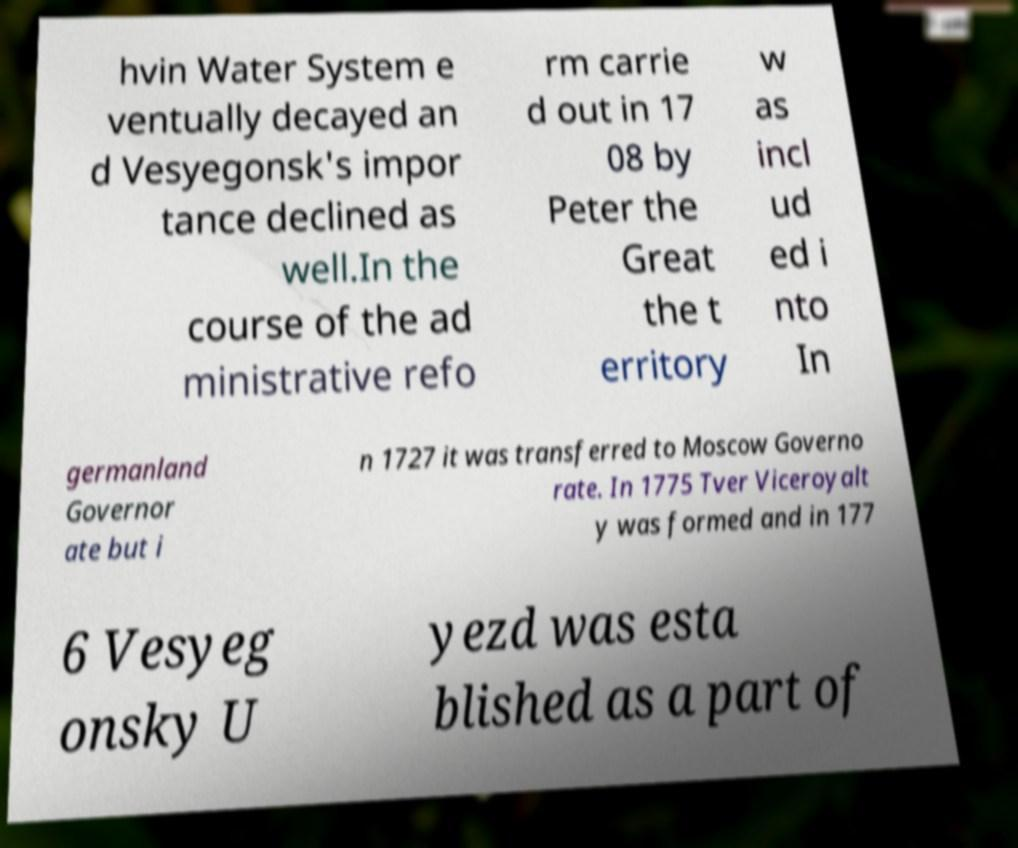Can you read and provide the text displayed in the image?This photo seems to have some interesting text. Can you extract and type it out for me? hvin Water System e ventually decayed an d Vesyegonsk's impor tance declined as well.In the course of the ad ministrative refo rm carrie d out in 17 08 by Peter the Great the t erritory w as incl ud ed i nto In germanland Governor ate but i n 1727 it was transferred to Moscow Governo rate. In 1775 Tver Viceroyalt y was formed and in 177 6 Vesyeg onsky U yezd was esta blished as a part of 